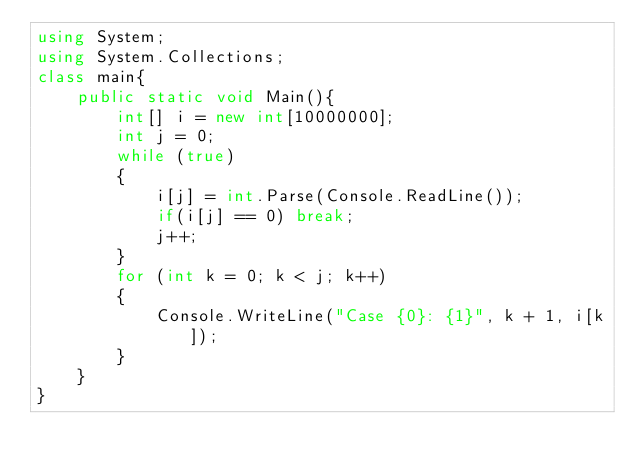Convert code to text. <code><loc_0><loc_0><loc_500><loc_500><_C#_>using System;
using System.Collections;
class main{
	public static void Main(){
		int[] i = new int[10000000];
		int j = 0;
		while (true)
		{
			i[j] = int.Parse(Console.ReadLine());
			if(i[j] == 0) break;
			j++;
		}
		for (int k = 0; k < j; k++)
		{
			Console.WriteLine("Case {0}: {1}", k + 1, i[k]);
		}
	}
}</code> 